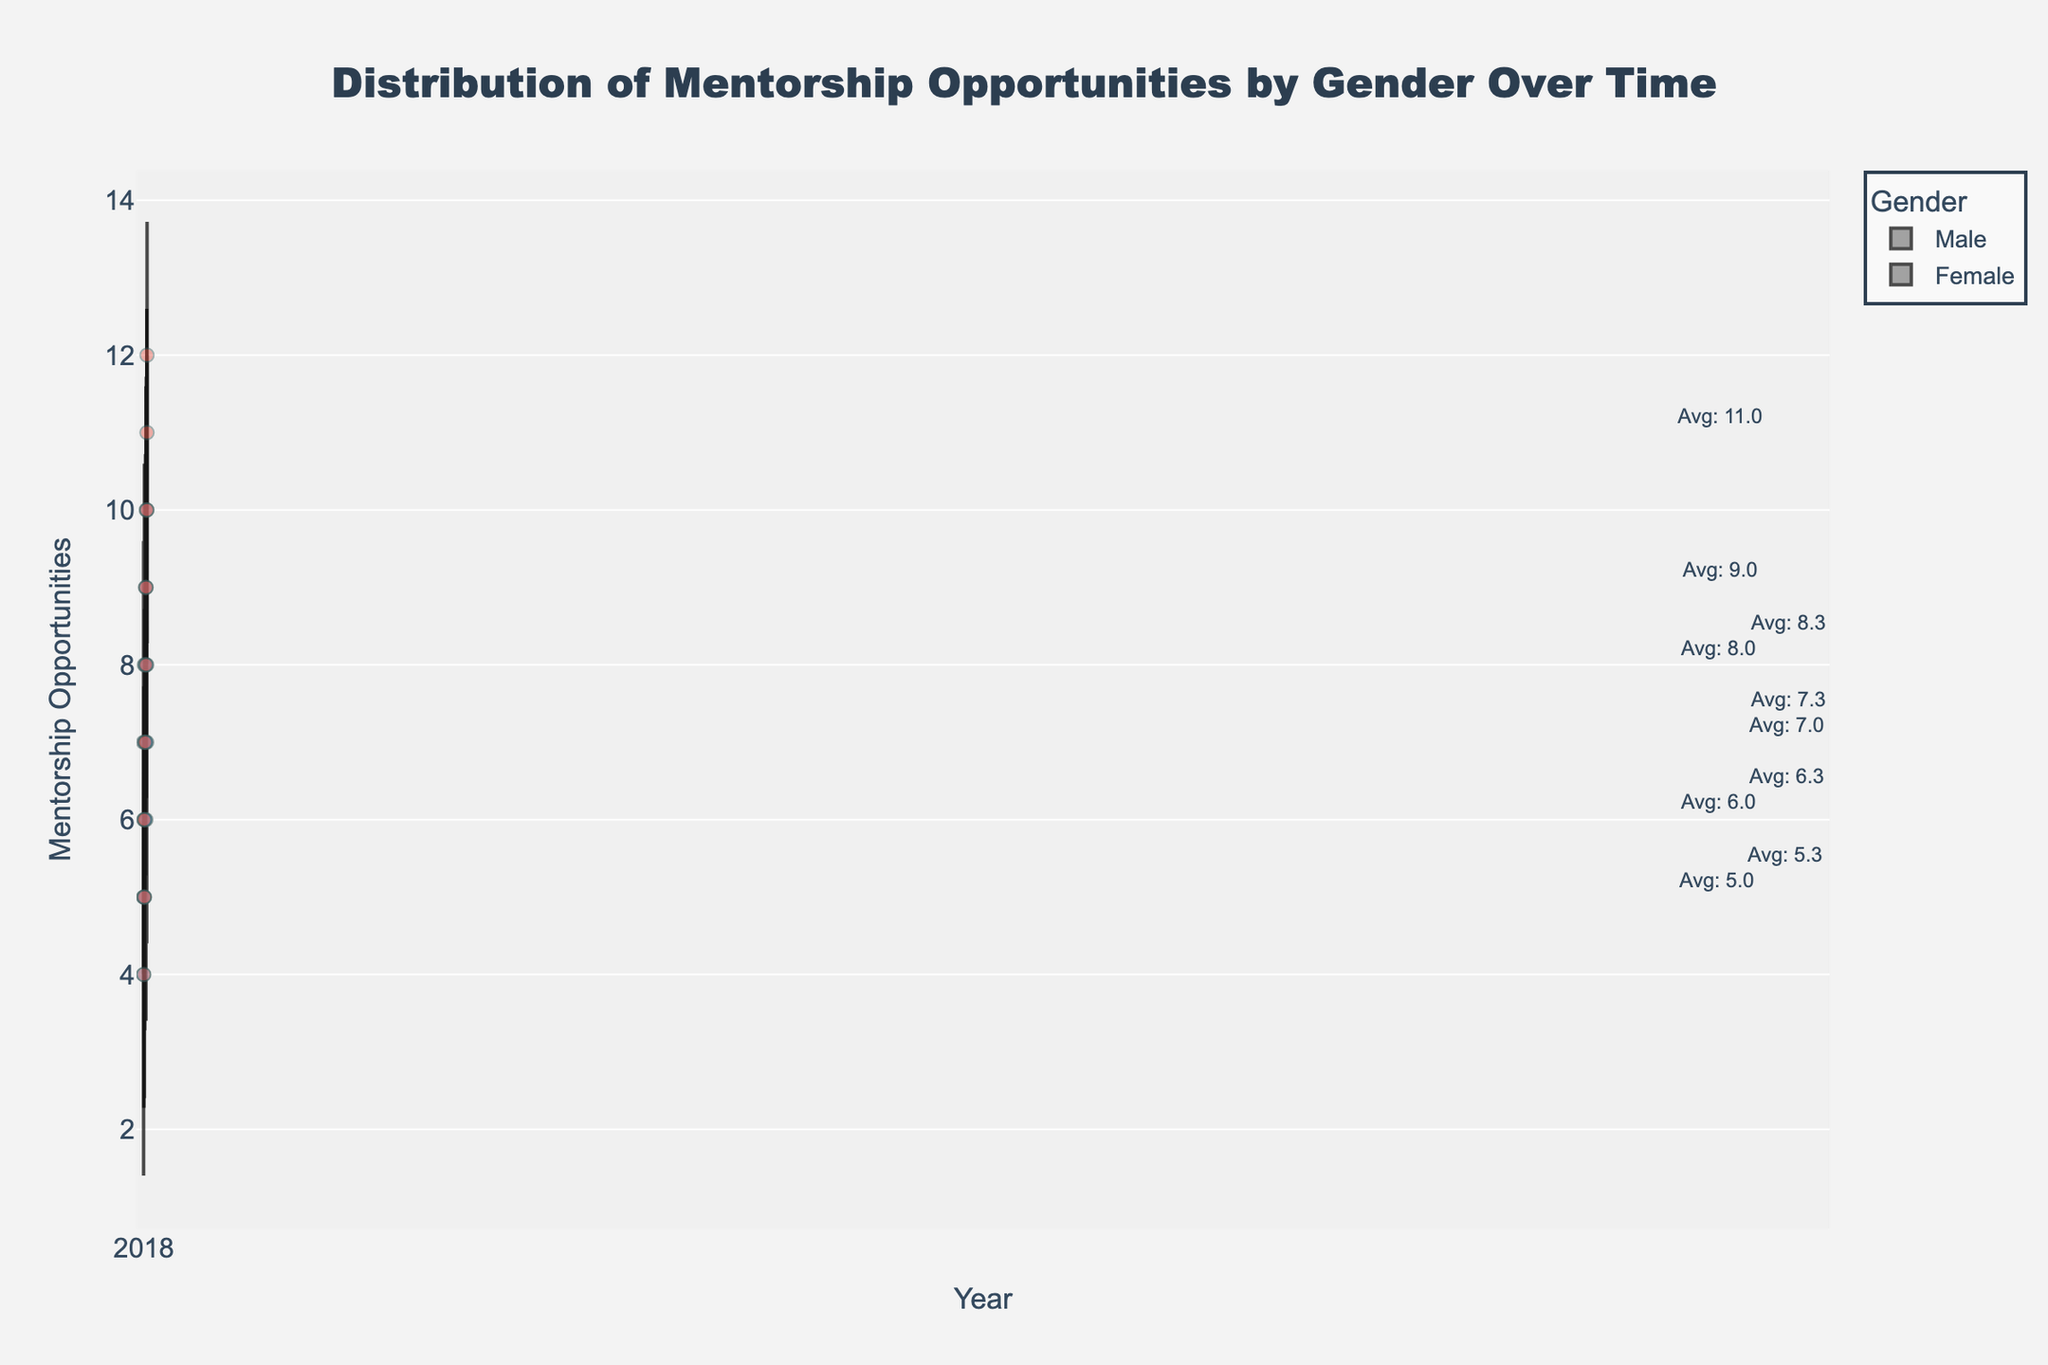What's the title of the figure? The title is found at the top of the figure and is typically larger and more prominent than other text. It provides a summary of what the visual is about.
Answer: Distribution of Mentorship Opportunities by Gender Over Time What do the x-axis and y-axis represent? The x-axis is usually the horizontal axis and here it represents the Year. The y-axis is the vertical axis and it represents Mentorship Opportunities received.
Answer: x-axis: Year; y-axis: Mentorship Opportunities Which gender had higher average values of mentorship opportunities in 2022? Look for the annotations or center points in the violins for each gender in 2022. Compare the average values denoted.
Answer: Female How many total data points are there for the year 2021? Carefully count the individual data points (dots) visible for both genders in 2021. Each dot represents a data point.
Answer: 6 Did the average mentorship opportunities for males increase or decrease from 2018 to 2022? Compare the average points annotated for males in 2018 and 2022. Note whether the value is higher or lower.
Answer: Increase Which year shows the most diverse distribution of mentorship opportunities for females? Check the width/spread of the female violin plots across the years; a wider spread indicates more diverse values.
Answer: 2022 What is the shape of the violin plot indicating about the distribution of mentorship opportunities between genders in 2020? Violin plots' width at various points shows density of data; wider sections denote higher density of values. Analyze the width and shape for both genders in 2020.
Answer: Similar shapes, but females have slightly more opportunities overall What is the median number of mentorship opportunities for males in 2019? Locate the horizontal line inside the male violin plot for 2019 which marks the median value.
Answer: 6 Compare the range of mentorship opportunities for both genders in 2018. Which gender has a wider range? Identify the top and bottom edges of the violin plots for each gender in 2018. The range is the distance between these edges.
Answer: Male Which year had the closest average mentorship opportunities between males and females? Compare the annotation marks for average values for both genders across all years. Find the year where the averages are closest.
Answer: 2020 